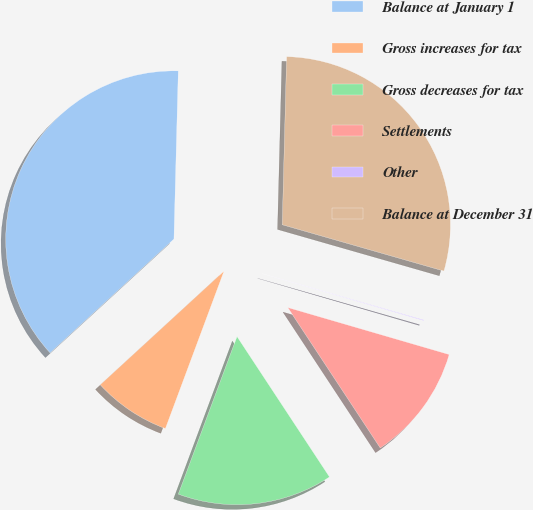Convert chart. <chart><loc_0><loc_0><loc_500><loc_500><pie_chart><fcel>Balance at January 1<fcel>Gross increases for tax<fcel>Gross decreases for tax<fcel>Settlements<fcel>Other<fcel>Balance at December 31<nl><fcel>37.24%<fcel>7.5%<fcel>14.94%<fcel>11.22%<fcel>0.07%<fcel>29.03%<nl></chart> 